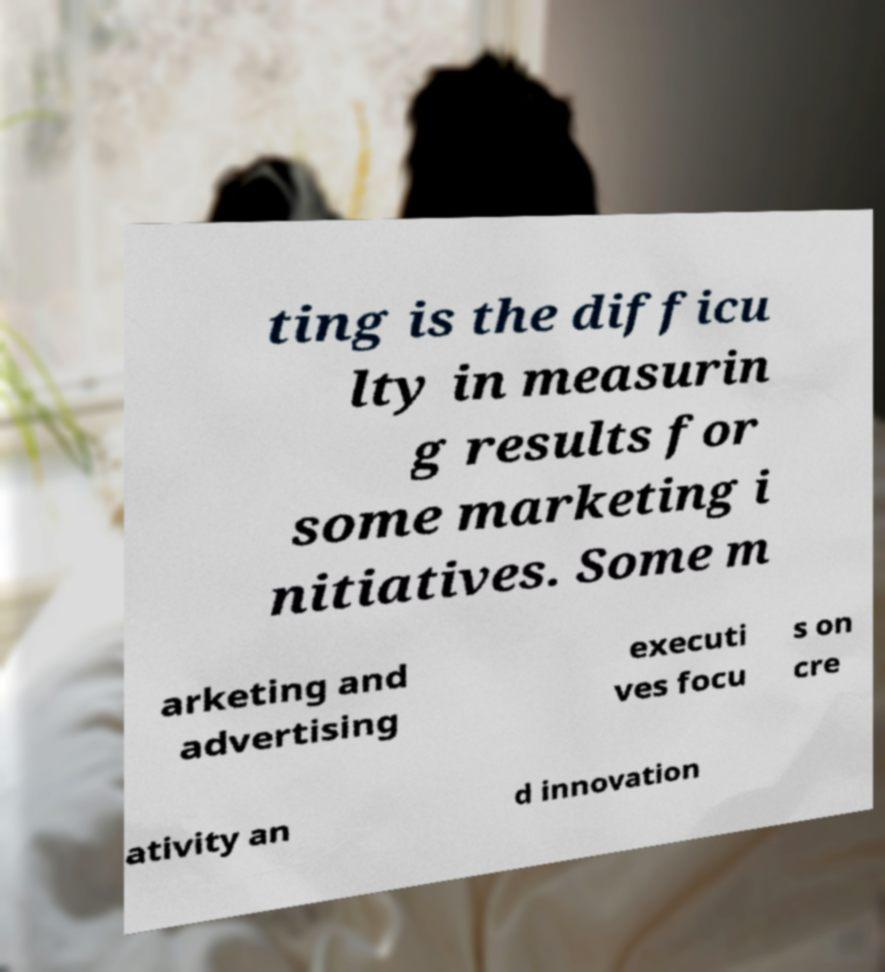Please identify and transcribe the text found in this image. ting is the difficu lty in measurin g results for some marketing i nitiatives. Some m arketing and advertising executi ves focu s on cre ativity an d innovation 